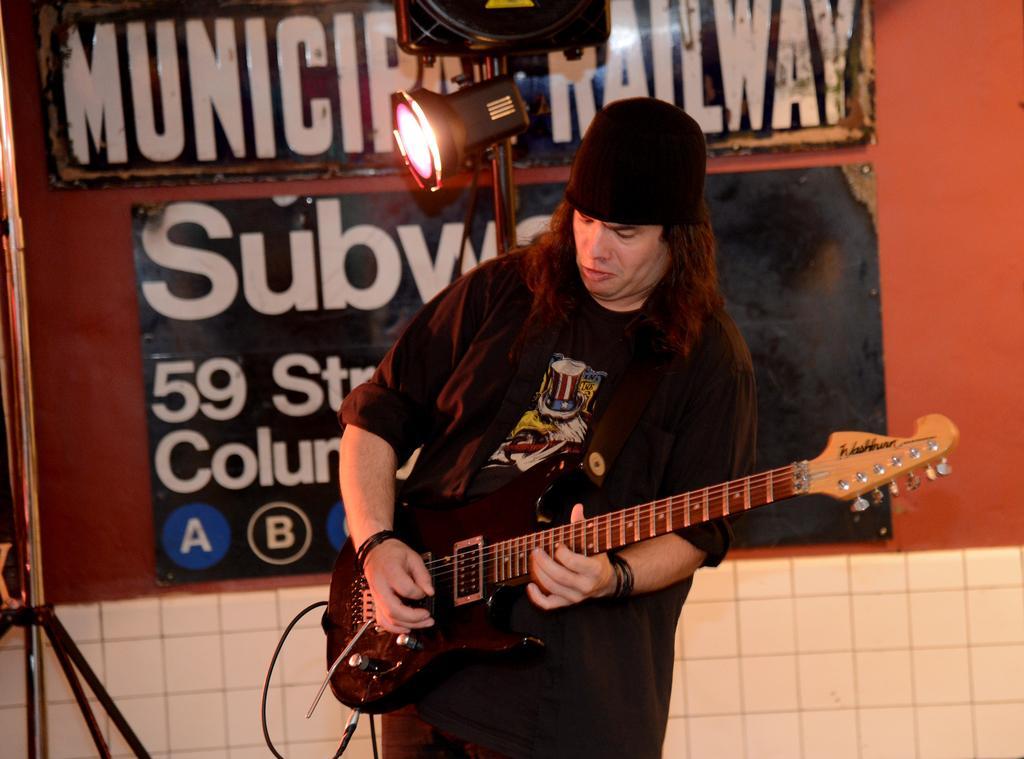Please provide a concise description of this image. In the image a man wearing a black cap and black dress is playing guitar. Behind him there is a red wall on it there are two board. There is a light attached to a stand behind him. 